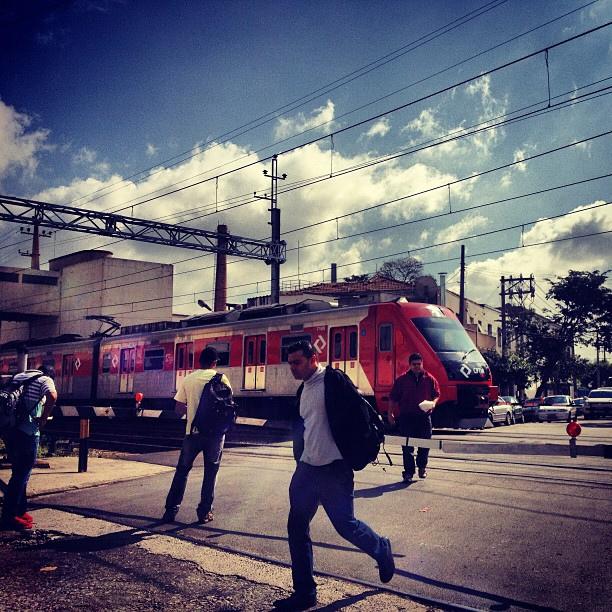How many people are there?
Keep it brief. 4. How many women are waiting for the train?
Be succinct. 0. IS the man in the background wearing a black tie?
Give a very brief answer. No. Who is wearing red shoes?
Quick response, please. Man on left. 